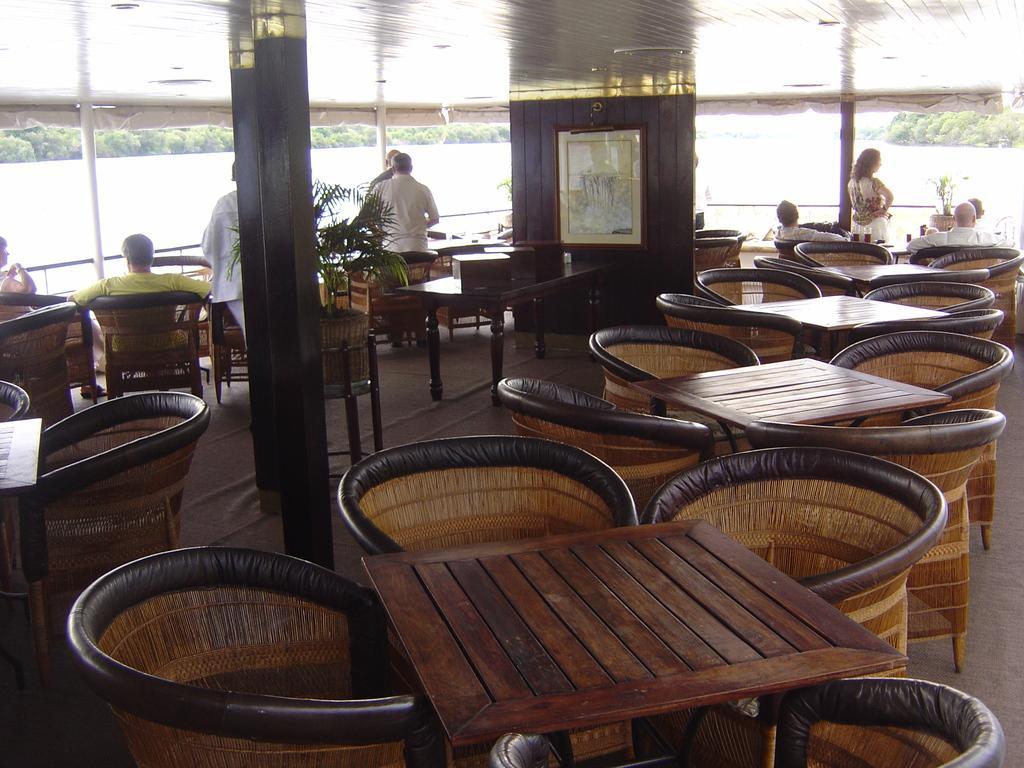In one or two sentences, can you explain what this image depicts? This image is taken inside a room. In the left side of the image there are few chairs and a person sitting on a chair. In the right side of the image there are few chairs and table and a persons sitting on a chairs beside them there is a pot with a plant. In the middle of the image there is a floor and a wall with the frame. At the background there are few plants. At the top most of the image there is a ceiling. 